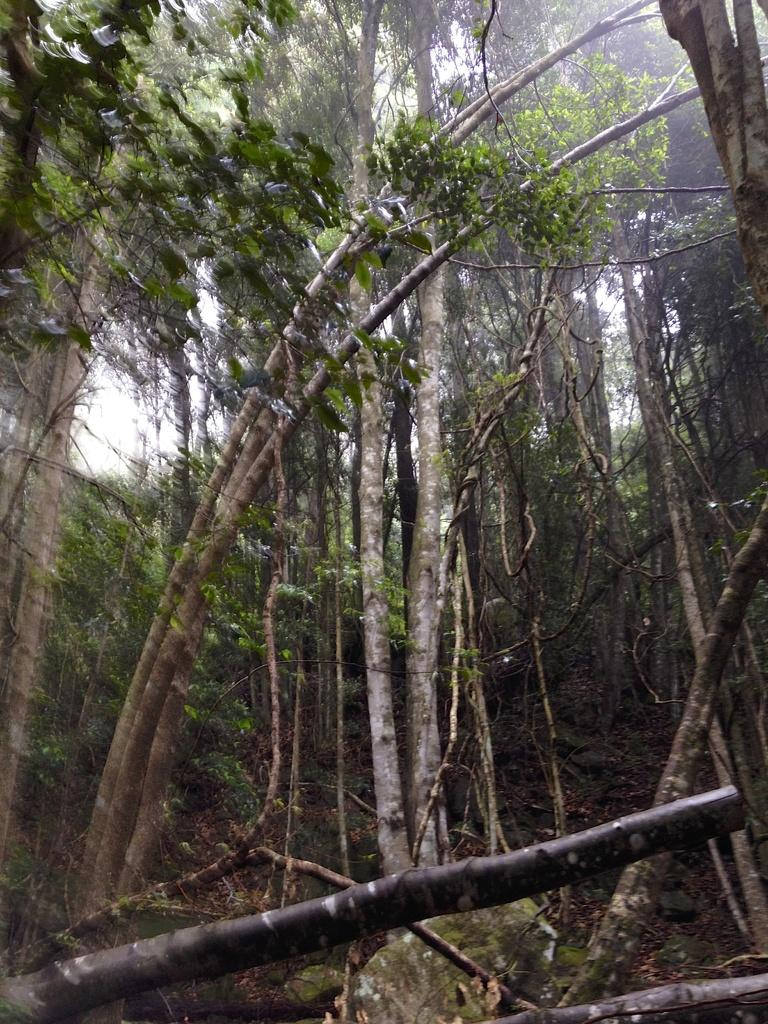What type of vegetation can be seen in the image? There are trees in the image. What part of the natural environment is visible in the image? The sky is visible in the background of the image. What type of prison can be seen in the image? There is no prison present in the image; it features trees and the sky. Can you tell me how many faces are visible in the image? There are no faces present in the image. 